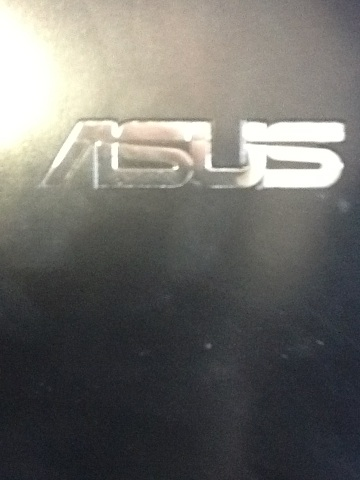In a realistic setting, what might a user say when they first unbox a device with this logo? Wow, this Asus laptop looks sleek and feels incredibly well-built. I can't wait to start using it for my graphic design work and explore all its features. 